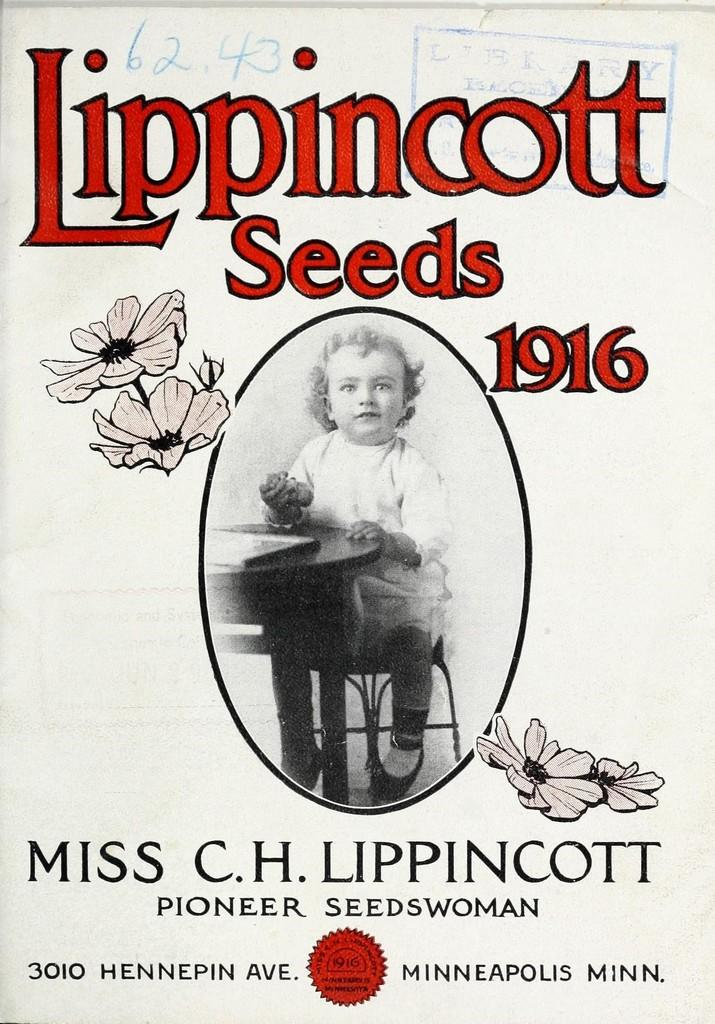What is the main object in the image? There is a pamphlet in the image. What is depicted inside the pamphlet? A child is sitting on a chair in the pamphlet. What colors are used for the writing in the pamphlet? The writing in the pamphlet is in red and black color. Can you tell me how many lips are visible in the image? There are no lips visible in the image; it features a pamphlet with a child sitting on a chair and writing in red and black color. 